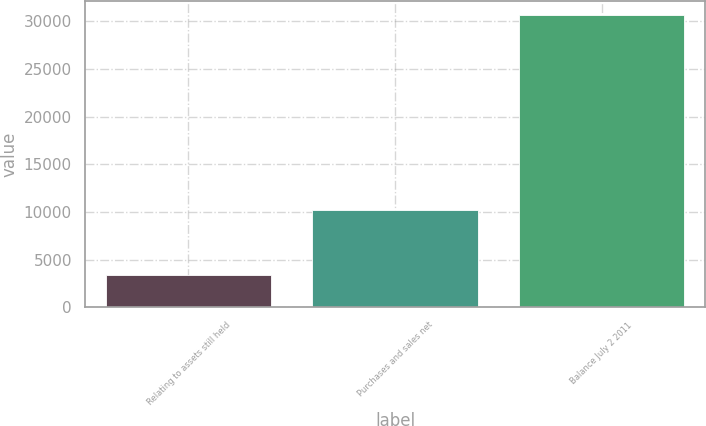<chart> <loc_0><loc_0><loc_500><loc_500><bar_chart><fcel>Relating to assets still held<fcel>Purchases and sales net<fcel>Balance July 2 2011<nl><fcel>3371<fcel>10179<fcel>30615<nl></chart> 